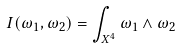<formula> <loc_0><loc_0><loc_500><loc_500>I ( \omega _ { 1 } , \omega _ { 2 } ) = \int _ { X ^ { 4 } } \omega _ { 1 } \wedge \omega _ { 2 }</formula> 